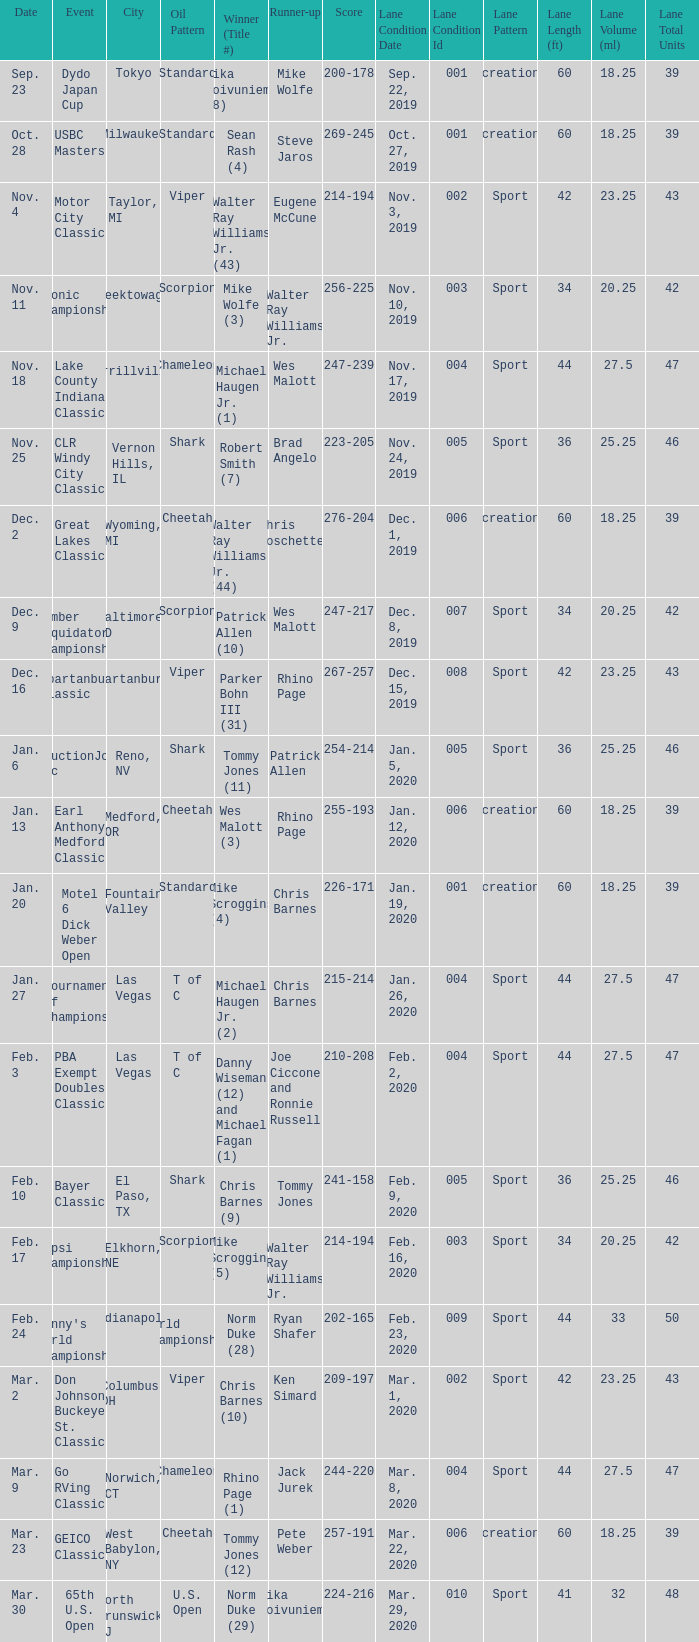Write the full table. {'header': ['Date', 'Event', 'City', 'Oil Pattern', 'Winner (Title #)', 'Runner-up', 'Score', 'Lane Condition Date', 'Lane Condition Id', 'Lane Pattern', 'Lane Length (ft)', 'Lane Volume (ml)', 'Lane Total Units'], 'rows': [['Sep. 23', 'Dydo Japan Cup', 'Tokyo', 'Standard', 'Mika Koivuniemi (8)', 'Mike Wolfe', '200-178', 'Sep. 22, 2019', '001', 'Recreational', '60', '18.25', '39'], ['Oct. 28', 'USBC Masters', 'Milwaukee', 'Standard', 'Sean Rash (4)', 'Steve Jaros', '269-245', 'Oct. 27, 2019', '001', 'Recreational', '60', '18.25', '39'], ['Nov. 4', 'Motor City Classic', 'Taylor, MI', 'Viper', 'Walter Ray Williams Jr. (43)', 'Eugene McCune', '214-194', 'Nov. 3, 2019', '002', 'Sport', '42', '23.25', '43'], ['Nov. 11', 'Etonic Championship', 'Cheektowaga, NY', 'Scorpion', 'Mike Wolfe (3)', 'Walter Ray Williams Jr.', '256-225', 'Nov. 10, 2019', '003', 'Sport', '34', '20.25', '42'], ['Nov. 18', 'Lake County Indiana Classic', 'Merrillville, IN', 'Chameleon', 'Michael Haugen Jr. (1)', 'Wes Malott', '247-239', 'Nov. 17, 2019', '004', 'Sport', '44', '27.5', '47'], ['Nov. 25', 'CLR Windy City Classic', 'Vernon Hills, IL', 'Shark', 'Robert Smith (7)', 'Brad Angelo', '223-205', 'Nov. 24, 2019', '005', 'Sport', '36', '25.25', '46'], ['Dec. 2', 'Great Lakes Classic', 'Wyoming, MI', 'Cheetah', 'Walter Ray Williams, Jr. (44)', 'Chris Loschetter', '276-204', 'Dec. 1, 2019', '006', 'Recreational', '60', '18.25', '39'], ['Dec. 9', 'Lumber Liquidators Championship', 'Baltimore, MD', 'Scorpion', 'Patrick Allen (10)', 'Wes Malott', '247-217', 'Dec. 8, 2019', '007', 'Sport', '34', '20.25', '42'], ['Dec. 16', 'Spartanburg Classic', 'Spartanburg, SC', 'Viper', 'Parker Bohn III (31)', 'Rhino Page', '267-257', 'Dec. 15, 2019', '008', 'Sport', '42', '23.25', '43'], ['Jan. 6', 'ConstructionJobs.com Classic', 'Reno, NV', 'Shark', 'Tommy Jones (11)', 'Patrick Allen', '254-214', 'Jan. 5, 2020', '005', 'Sport', '36', '25.25', '46'], ['Jan. 13', 'Earl Anthony Medford Classic', 'Medford, OR', 'Cheetah', 'Wes Malott (3)', 'Rhino Page', '255-193', 'Jan. 12, 2020', '006', 'Recreational', '60', '18.25', '39'], ['Jan. 20', 'Motel 6 Dick Weber Open', 'Fountain Valley', 'Standard', 'Mike Scroggins (4)', 'Chris Barnes', '226-171', 'Jan. 19, 2020', '001', 'Recreational', '60', '18.25', '39'], ['Jan. 27', 'Tournament Of Champions', 'Las Vegas', 'T of C', 'Michael Haugen Jr. (2)', 'Chris Barnes', '215-214', 'Jan. 26, 2020', '004', 'Sport', '44', '27.5', '47'], ['Feb. 3', 'PBA Exempt Doubles Classic', 'Las Vegas', 'T of C', 'Danny Wiseman (12) and Michael Fagan (1)', 'Joe Ciccone and Ronnie Russell', '210-208', 'Feb. 2, 2020', '004', 'Sport', '44', '27.5', '47'], ['Feb. 10', 'Bayer Classic', 'El Paso, TX', 'Shark', 'Chris Barnes (9)', 'Tommy Jones', '241-158', 'Feb. 9, 2020', '005', 'Sport', '36', '25.25', '46'], ['Feb. 17', 'Pepsi Championship', 'Elkhorn, NE', 'Scorpion', 'Mike Scroggins (5)', 'Walter Ray Williams Jr.', '214-194', 'Feb. 16, 2020', '003', 'Sport', '34', '20.25', '42'], ['Feb. 24', "Denny's World Championship", 'Indianapolis', 'World Championship', 'Norm Duke (28)', 'Ryan Shafer', '202-165', 'Feb. 23, 2020', '009', 'Sport', '44', '33', '50'], ['Mar. 2', 'Don Johnson Buckeye St. Classic', 'Columbus, OH', 'Viper', 'Chris Barnes (10)', 'Ken Simard', '209-197', 'Mar. 1, 2020', '002', 'Sport', '42', '23.25', '43'], ['Mar. 9', 'Go RVing Classic', 'Norwich, CT', 'Chameleon', 'Rhino Page (1)', 'Jack Jurek', '244-220', 'Mar. 8, 2020', '004', 'Sport', '44', '27.5', '47'], ['Mar. 23', 'GEICO Classic', 'West Babylon, NY', 'Cheetah', 'Tommy Jones (12)', 'Pete Weber', '257-191', 'Mar. 22, 2020', '006', 'Recreational', '60', '18.25', '39'], ['Mar. 30', '65th U.S. Open', 'North Brunswick, NJ', 'U.S. Open', 'Norm Duke (29)', 'Mika Koivuniemi', '224-216', 'Mar. 29, 2020', '010', 'Sport', '41', '32', '48']]} Name the Event which has a Winner (Title #) of parker bohn iii (31)? Spartanburg Classic. 